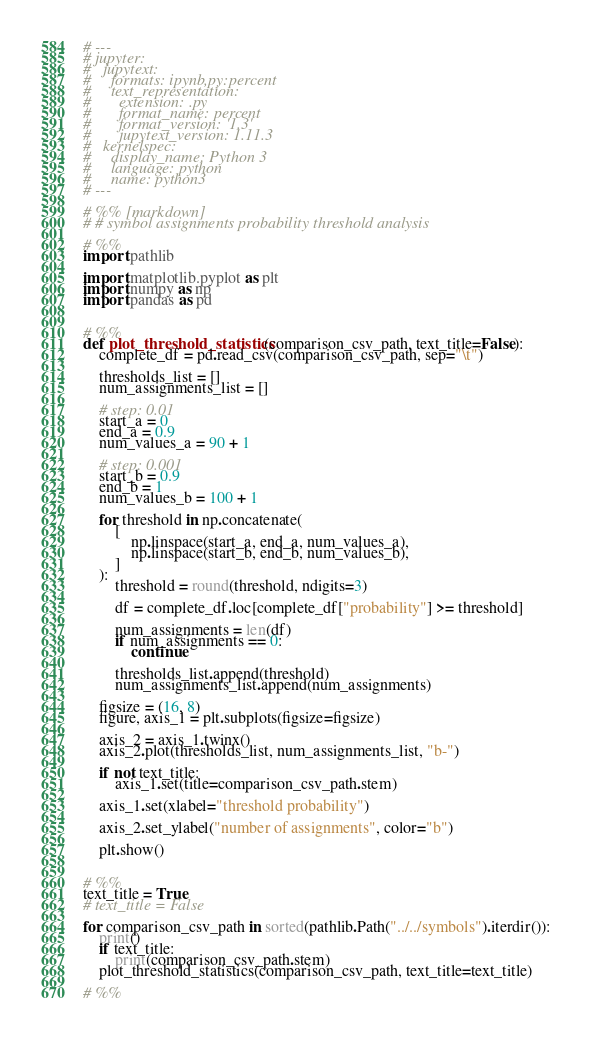<code> <loc_0><loc_0><loc_500><loc_500><_Python_># ---
# jupyter:
#   jupytext:
#     formats: ipynb,py:percent
#     text_representation:
#       extension: .py
#       format_name: percent
#       format_version: '1.3'
#       jupytext_version: 1.11.3
#   kernelspec:
#     display_name: Python 3
#     language: python
#     name: python3
# ---

# %% [markdown]
# # symbol assignments probability threshold analysis

# %%
import pathlib

import matplotlib.pyplot as plt
import numpy as np
import pandas as pd


# %%
def plot_threshold_statistics(comparison_csv_path, text_title=False):
    complete_df = pd.read_csv(comparison_csv_path, sep="\t")

    thresholds_list = []
    num_assignments_list = []

    # step: 0.01
    start_a = 0
    end_a = 0.9
    num_values_a = 90 + 1

    # step: 0.001
    start_b = 0.9
    end_b = 1
    num_values_b = 100 + 1

    for threshold in np.concatenate(
        [
            np.linspace(start_a, end_a, num_values_a),
            np.linspace(start_b, end_b, num_values_b),
        ]
    ):
        threshold = round(threshold, ndigits=3)

        df = complete_df.loc[complete_df["probability"] >= threshold]

        num_assignments = len(df)
        if num_assignments == 0:
            continue

        thresholds_list.append(threshold)
        num_assignments_list.append(num_assignments)

    figsize = (16, 8)
    figure, axis_1 = plt.subplots(figsize=figsize)

    axis_2 = axis_1.twinx()
    axis_2.plot(thresholds_list, num_assignments_list, "b-")

    if not text_title:
        axis_1.set(title=comparison_csv_path.stem)

    axis_1.set(xlabel="threshold probability")

    axis_2.set_ylabel("number of assignments", color="b")

    plt.show()


# %%
text_title = True
# text_title = False

for comparison_csv_path in sorted(pathlib.Path("../../symbols").iterdir()):
    print()
    if text_title:
        print(comparison_csv_path.stem)
    plot_threshold_statistics(comparison_csv_path, text_title=text_title)

# %%
</code> 